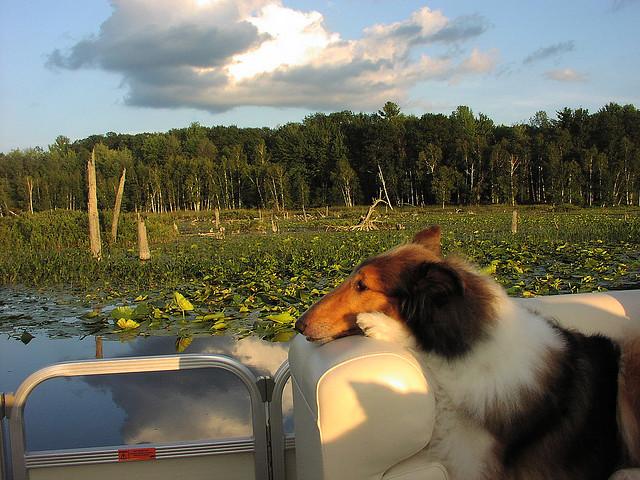Where is the dog?
Concise answer only. Boat. What mode of transportation is the dog on?
Be succinct. Boat. What type of dog is this?
Be succinct. Collie. 